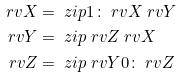<formula> <loc_0><loc_0><loc_500><loc_500>\ r v { X } & = \ z i p { 1 \colon \ r v { X } } { \ r v { Y } } \\ \ r v { Y } & = \ z i p { \ r v { Z } } { \ r v { X } } \\ \ r v { Z } & = \ z i p { \ r v { Y } } { 0 \colon \ r v { Z } }</formula> 